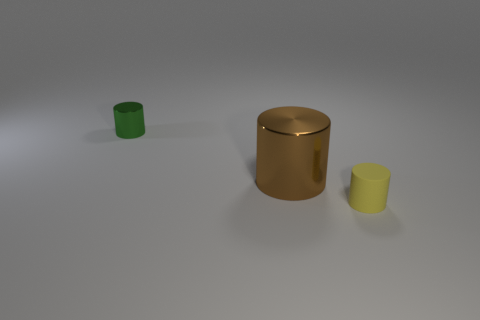There is another object that is the same size as the yellow matte object; what is its color?
Offer a terse response. Green. Is there a yellow thing that has the same shape as the green object?
Provide a succinct answer. Yes. What material is the tiny cylinder right of the tiny cylinder that is behind the small thing right of the tiny metallic object?
Keep it short and to the point. Rubber. How many other things are there of the same size as the brown cylinder?
Your answer should be very brief. 0. What is the color of the rubber object?
Offer a terse response. Yellow. How many matte things are either tiny purple objects or large brown objects?
Your answer should be compact. 0. Is there anything else that has the same material as the small green object?
Make the answer very short. Yes. What size is the brown metal cylinder on the right side of the small cylinder on the left side of the tiny object right of the tiny green metal cylinder?
Give a very brief answer. Large. There is a small thing to the left of the small matte thing; is its color the same as the tiny thing right of the brown shiny cylinder?
Offer a terse response. No. There is a tiny rubber object; what number of small yellow cylinders are left of it?
Your response must be concise. 0. 